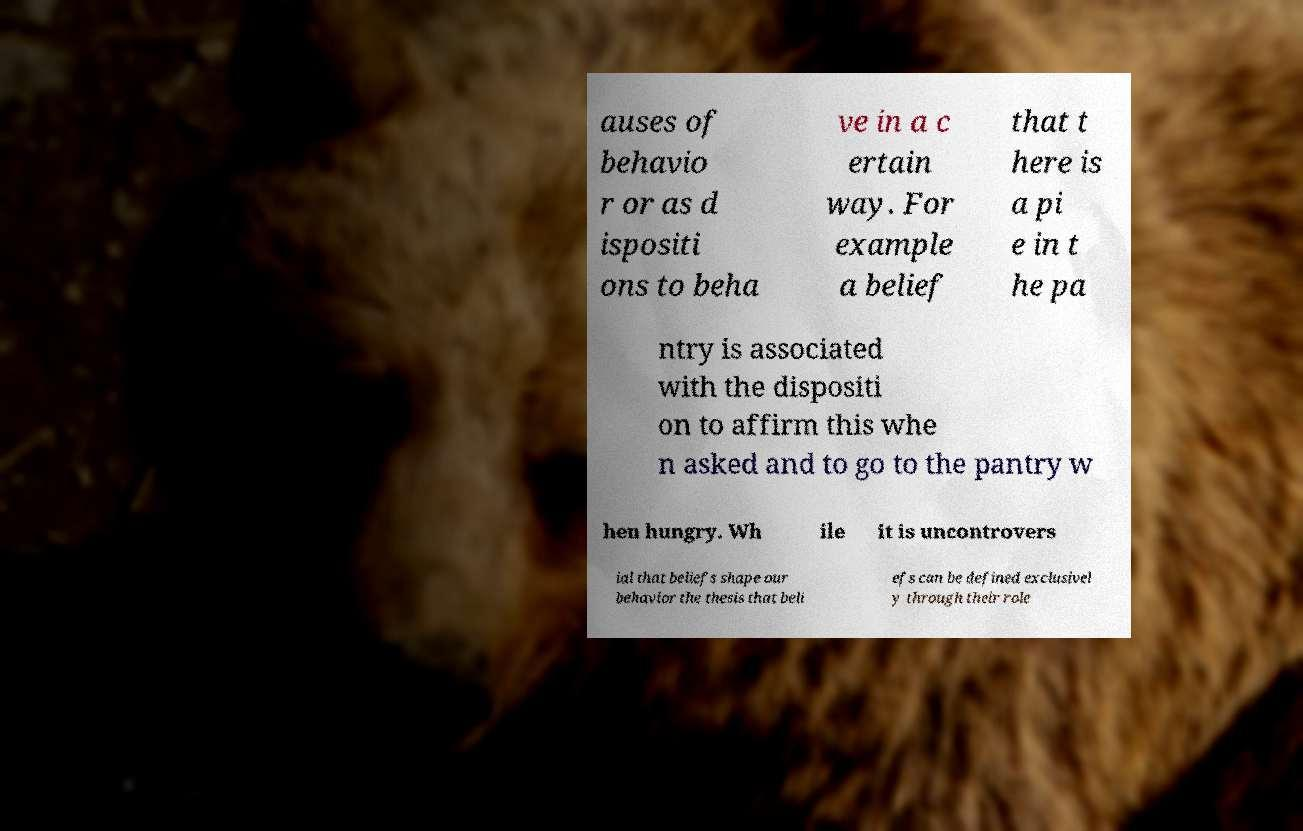Please identify and transcribe the text found in this image. auses of behavio r or as d ispositi ons to beha ve in a c ertain way. For example a belief that t here is a pi e in t he pa ntry is associated with the dispositi on to affirm this whe n asked and to go to the pantry w hen hungry. Wh ile it is uncontrovers ial that beliefs shape our behavior the thesis that beli efs can be defined exclusivel y through their role 